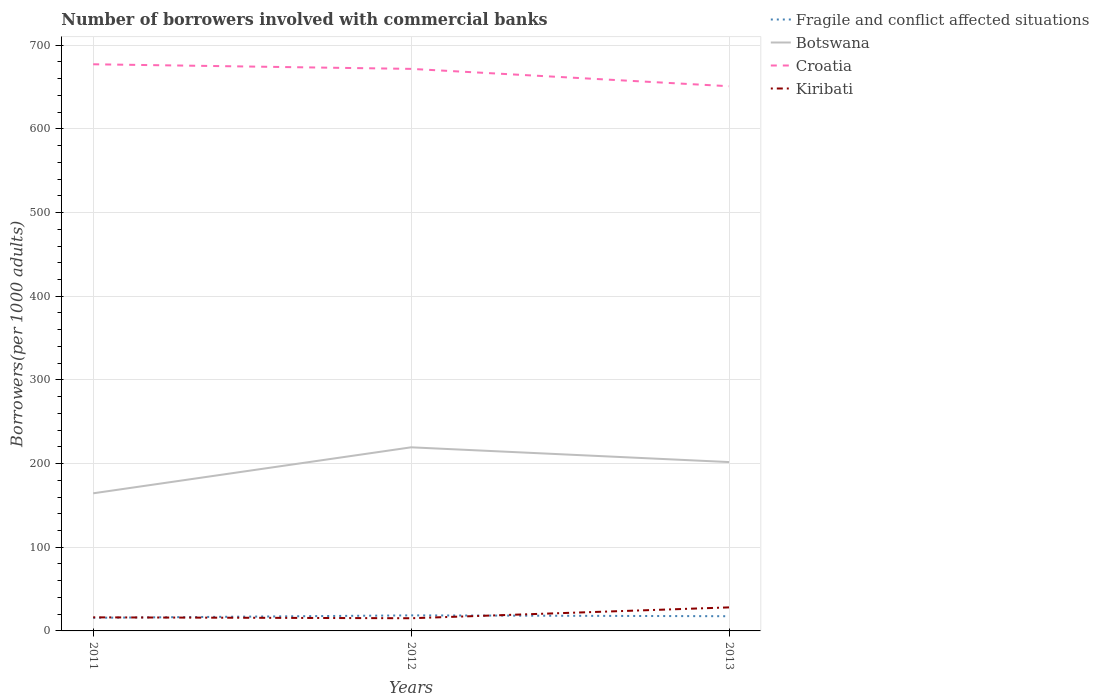How many different coloured lines are there?
Provide a short and direct response. 4. Does the line corresponding to Croatia intersect with the line corresponding to Kiribati?
Keep it short and to the point. No. Across all years, what is the maximum number of borrowers involved with commercial banks in Fragile and conflict affected situations?
Provide a short and direct response. 15.67. In which year was the number of borrowers involved with commercial banks in Fragile and conflict affected situations maximum?
Your answer should be very brief. 2011. What is the total number of borrowers involved with commercial banks in Fragile and conflict affected situations in the graph?
Provide a succinct answer. -2.91. What is the difference between the highest and the second highest number of borrowers involved with commercial banks in Botswana?
Offer a very short reply. 54.96. What is the difference between the highest and the lowest number of borrowers involved with commercial banks in Kiribati?
Give a very brief answer. 1. Is the number of borrowers involved with commercial banks in Fragile and conflict affected situations strictly greater than the number of borrowers involved with commercial banks in Croatia over the years?
Keep it short and to the point. Yes. Does the graph contain any zero values?
Offer a very short reply. No. Does the graph contain grids?
Keep it short and to the point. Yes. How many legend labels are there?
Provide a succinct answer. 4. How are the legend labels stacked?
Your answer should be very brief. Vertical. What is the title of the graph?
Offer a terse response. Number of borrowers involved with commercial banks. What is the label or title of the Y-axis?
Provide a succinct answer. Borrowers(per 1000 adults). What is the Borrowers(per 1000 adults) of Fragile and conflict affected situations in 2011?
Your response must be concise. 15.67. What is the Borrowers(per 1000 adults) in Botswana in 2011?
Offer a terse response. 164.48. What is the Borrowers(per 1000 adults) in Croatia in 2011?
Provide a succinct answer. 677.25. What is the Borrowers(per 1000 adults) in Kiribati in 2011?
Offer a terse response. 16.23. What is the Borrowers(per 1000 adults) of Fragile and conflict affected situations in 2012?
Offer a very short reply. 18.58. What is the Borrowers(per 1000 adults) of Botswana in 2012?
Keep it short and to the point. 219.44. What is the Borrowers(per 1000 adults) in Croatia in 2012?
Offer a terse response. 671.74. What is the Borrowers(per 1000 adults) of Kiribati in 2012?
Keep it short and to the point. 15.15. What is the Borrowers(per 1000 adults) in Fragile and conflict affected situations in 2013?
Provide a succinct answer. 17.58. What is the Borrowers(per 1000 adults) of Botswana in 2013?
Give a very brief answer. 201.82. What is the Borrowers(per 1000 adults) in Croatia in 2013?
Keep it short and to the point. 651.02. What is the Borrowers(per 1000 adults) in Kiribati in 2013?
Your answer should be very brief. 28.13. Across all years, what is the maximum Borrowers(per 1000 adults) of Fragile and conflict affected situations?
Give a very brief answer. 18.58. Across all years, what is the maximum Borrowers(per 1000 adults) of Botswana?
Keep it short and to the point. 219.44. Across all years, what is the maximum Borrowers(per 1000 adults) of Croatia?
Your answer should be very brief. 677.25. Across all years, what is the maximum Borrowers(per 1000 adults) of Kiribati?
Provide a succinct answer. 28.13. Across all years, what is the minimum Borrowers(per 1000 adults) of Fragile and conflict affected situations?
Provide a short and direct response. 15.67. Across all years, what is the minimum Borrowers(per 1000 adults) of Botswana?
Ensure brevity in your answer.  164.48. Across all years, what is the minimum Borrowers(per 1000 adults) in Croatia?
Offer a terse response. 651.02. Across all years, what is the minimum Borrowers(per 1000 adults) of Kiribati?
Give a very brief answer. 15.15. What is the total Borrowers(per 1000 adults) of Fragile and conflict affected situations in the graph?
Your response must be concise. 51.83. What is the total Borrowers(per 1000 adults) of Botswana in the graph?
Ensure brevity in your answer.  585.73. What is the total Borrowers(per 1000 adults) in Croatia in the graph?
Ensure brevity in your answer.  2000. What is the total Borrowers(per 1000 adults) in Kiribati in the graph?
Your answer should be compact. 59.51. What is the difference between the Borrowers(per 1000 adults) in Fragile and conflict affected situations in 2011 and that in 2012?
Provide a succinct answer. -2.91. What is the difference between the Borrowers(per 1000 adults) in Botswana in 2011 and that in 2012?
Your response must be concise. -54.96. What is the difference between the Borrowers(per 1000 adults) in Croatia in 2011 and that in 2012?
Keep it short and to the point. 5.51. What is the difference between the Borrowers(per 1000 adults) of Kiribati in 2011 and that in 2012?
Ensure brevity in your answer.  1.08. What is the difference between the Borrowers(per 1000 adults) in Fragile and conflict affected situations in 2011 and that in 2013?
Give a very brief answer. -1.91. What is the difference between the Borrowers(per 1000 adults) of Botswana in 2011 and that in 2013?
Provide a short and direct response. -37.34. What is the difference between the Borrowers(per 1000 adults) of Croatia in 2011 and that in 2013?
Offer a terse response. 26.23. What is the difference between the Borrowers(per 1000 adults) of Kiribati in 2011 and that in 2013?
Offer a terse response. -11.9. What is the difference between the Borrowers(per 1000 adults) of Fragile and conflict affected situations in 2012 and that in 2013?
Offer a terse response. 1. What is the difference between the Borrowers(per 1000 adults) in Botswana in 2012 and that in 2013?
Your answer should be compact. 17.62. What is the difference between the Borrowers(per 1000 adults) in Croatia in 2012 and that in 2013?
Ensure brevity in your answer.  20.72. What is the difference between the Borrowers(per 1000 adults) in Kiribati in 2012 and that in 2013?
Make the answer very short. -12.98. What is the difference between the Borrowers(per 1000 adults) in Fragile and conflict affected situations in 2011 and the Borrowers(per 1000 adults) in Botswana in 2012?
Provide a short and direct response. -203.77. What is the difference between the Borrowers(per 1000 adults) of Fragile and conflict affected situations in 2011 and the Borrowers(per 1000 adults) of Croatia in 2012?
Provide a short and direct response. -656.07. What is the difference between the Borrowers(per 1000 adults) of Fragile and conflict affected situations in 2011 and the Borrowers(per 1000 adults) of Kiribati in 2012?
Your answer should be compact. 0.52. What is the difference between the Borrowers(per 1000 adults) in Botswana in 2011 and the Borrowers(per 1000 adults) in Croatia in 2012?
Your answer should be compact. -507.26. What is the difference between the Borrowers(per 1000 adults) of Botswana in 2011 and the Borrowers(per 1000 adults) of Kiribati in 2012?
Provide a short and direct response. 149.32. What is the difference between the Borrowers(per 1000 adults) of Croatia in 2011 and the Borrowers(per 1000 adults) of Kiribati in 2012?
Provide a succinct answer. 662.09. What is the difference between the Borrowers(per 1000 adults) in Fragile and conflict affected situations in 2011 and the Borrowers(per 1000 adults) in Botswana in 2013?
Make the answer very short. -186.15. What is the difference between the Borrowers(per 1000 adults) of Fragile and conflict affected situations in 2011 and the Borrowers(per 1000 adults) of Croatia in 2013?
Ensure brevity in your answer.  -635.35. What is the difference between the Borrowers(per 1000 adults) of Fragile and conflict affected situations in 2011 and the Borrowers(per 1000 adults) of Kiribati in 2013?
Offer a terse response. -12.46. What is the difference between the Borrowers(per 1000 adults) in Botswana in 2011 and the Borrowers(per 1000 adults) in Croatia in 2013?
Ensure brevity in your answer.  -486.54. What is the difference between the Borrowers(per 1000 adults) in Botswana in 2011 and the Borrowers(per 1000 adults) in Kiribati in 2013?
Ensure brevity in your answer.  136.35. What is the difference between the Borrowers(per 1000 adults) of Croatia in 2011 and the Borrowers(per 1000 adults) of Kiribati in 2013?
Offer a terse response. 649.12. What is the difference between the Borrowers(per 1000 adults) of Fragile and conflict affected situations in 2012 and the Borrowers(per 1000 adults) of Botswana in 2013?
Ensure brevity in your answer.  -183.23. What is the difference between the Borrowers(per 1000 adults) in Fragile and conflict affected situations in 2012 and the Borrowers(per 1000 adults) in Croatia in 2013?
Your answer should be compact. -632.43. What is the difference between the Borrowers(per 1000 adults) in Fragile and conflict affected situations in 2012 and the Borrowers(per 1000 adults) in Kiribati in 2013?
Offer a terse response. -9.55. What is the difference between the Borrowers(per 1000 adults) in Botswana in 2012 and the Borrowers(per 1000 adults) in Croatia in 2013?
Your answer should be very brief. -431.58. What is the difference between the Borrowers(per 1000 adults) in Botswana in 2012 and the Borrowers(per 1000 adults) in Kiribati in 2013?
Your response must be concise. 191.31. What is the difference between the Borrowers(per 1000 adults) in Croatia in 2012 and the Borrowers(per 1000 adults) in Kiribati in 2013?
Provide a short and direct response. 643.61. What is the average Borrowers(per 1000 adults) in Fragile and conflict affected situations per year?
Keep it short and to the point. 17.28. What is the average Borrowers(per 1000 adults) of Botswana per year?
Offer a very short reply. 195.24. What is the average Borrowers(per 1000 adults) in Croatia per year?
Keep it short and to the point. 666.67. What is the average Borrowers(per 1000 adults) in Kiribati per year?
Your answer should be very brief. 19.84. In the year 2011, what is the difference between the Borrowers(per 1000 adults) of Fragile and conflict affected situations and Borrowers(per 1000 adults) of Botswana?
Offer a terse response. -148.81. In the year 2011, what is the difference between the Borrowers(per 1000 adults) in Fragile and conflict affected situations and Borrowers(per 1000 adults) in Croatia?
Keep it short and to the point. -661.58. In the year 2011, what is the difference between the Borrowers(per 1000 adults) in Fragile and conflict affected situations and Borrowers(per 1000 adults) in Kiribati?
Offer a terse response. -0.56. In the year 2011, what is the difference between the Borrowers(per 1000 adults) in Botswana and Borrowers(per 1000 adults) in Croatia?
Provide a short and direct response. -512.77. In the year 2011, what is the difference between the Borrowers(per 1000 adults) of Botswana and Borrowers(per 1000 adults) of Kiribati?
Your answer should be very brief. 148.25. In the year 2011, what is the difference between the Borrowers(per 1000 adults) of Croatia and Borrowers(per 1000 adults) of Kiribati?
Provide a short and direct response. 661.02. In the year 2012, what is the difference between the Borrowers(per 1000 adults) of Fragile and conflict affected situations and Borrowers(per 1000 adults) of Botswana?
Ensure brevity in your answer.  -200.86. In the year 2012, what is the difference between the Borrowers(per 1000 adults) of Fragile and conflict affected situations and Borrowers(per 1000 adults) of Croatia?
Your response must be concise. -653.16. In the year 2012, what is the difference between the Borrowers(per 1000 adults) in Fragile and conflict affected situations and Borrowers(per 1000 adults) in Kiribati?
Your response must be concise. 3.43. In the year 2012, what is the difference between the Borrowers(per 1000 adults) in Botswana and Borrowers(per 1000 adults) in Croatia?
Your answer should be very brief. -452.3. In the year 2012, what is the difference between the Borrowers(per 1000 adults) of Botswana and Borrowers(per 1000 adults) of Kiribati?
Make the answer very short. 204.28. In the year 2012, what is the difference between the Borrowers(per 1000 adults) in Croatia and Borrowers(per 1000 adults) in Kiribati?
Give a very brief answer. 656.59. In the year 2013, what is the difference between the Borrowers(per 1000 adults) in Fragile and conflict affected situations and Borrowers(per 1000 adults) in Botswana?
Give a very brief answer. -184.24. In the year 2013, what is the difference between the Borrowers(per 1000 adults) of Fragile and conflict affected situations and Borrowers(per 1000 adults) of Croatia?
Your answer should be very brief. -633.44. In the year 2013, what is the difference between the Borrowers(per 1000 adults) in Fragile and conflict affected situations and Borrowers(per 1000 adults) in Kiribati?
Your answer should be very brief. -10.55. In the year 2013, what is the difference between the Borrowers(per 1000 adults) of Botswana and Borrowers(per 1000 adults) of Croatia?
Provide a succinct answer. -449.2. In the year 2013, what is the difference between the Borrowers(per 1000 adults) in Botswana and Borrowers(per 1000 adults) in Kiribati?
Keep it short and to the point. 173.69. In the year 2013, what is the difference between the Borrowers(per 1000 adults) of Croatia and Borrowers(per 1000 adults) of Kiribati?
Offer a very short reply. 622.89. What is the ratio of the Borrowers(per 1000 adults) in Fragile and conflict affected situations in 2011 to that in 2012?
Keep it short and to the point. 0.84. What is the ratio of the Borrowers(per 1000 adults) in Botswana in 2011 to that in 2012?
Offer a very short reply. 0.75. What is the ratio of the Borrowers(per 1000 adults) of Croatia in 2011 to that in 2012?
Offer a terse response. 1.01. What is the ratio of the Borrowers(per 1000 adults) of Kiribati in 2011 to that in 2012?
Provide a short and direct response. 1.07. What is the ratio of the Borrowers(per 1000 adults) in Fragile and conflict affected situations in 2011 to that in 2013?
Your answer should be very brief. 0.89. What is the ratio of the Borrowers(per 1000 adults) of Botswana in 2011 to that in 2013?
Your answer should be compact. 0.81. What is the ratio of the Borrowers(per 1000 adults) in Croatia in 2011 to that in 2013?
Make the answer very short. 1.04. What is the ratio of the Borrowers(per 1000 adults) in Kiribati in 2011 to that in 2013?
Make the answer very short. 0.58. What is the ratio of the Borrowers(per 1000 adults) of Fragile and conflict affected situations in 2012 to that in 2013?
Offer a terse response. 1.06. What is the ratio of the Borrowers(per 1000 adults) in Botswana in 2012 to that in 2013?
Your answer should be compact. 1.09. What is the ratio of the Borrowers(per 1000 adults) in Croatia in 2012 to that in 2013?
Keep it short and to the point. 1.03. What is the ratio of the Borrowers(per 1000 adults) of Kiribati in 2012 to that in 2013?
Give a very brief answer. 0.54. What is the difference between the highest and the second highest Borrowers(per 1000 adults) in Fragile and conflict affected situations?
Your response must be concise. 1. What is the difference between the highest and the second highest Borrowers(per 1000 adults) of Botswana?
Your answer should be compact. 17.62. What is the difference between the highest and the second highest Borrowers(per 1000 adults) in Croatia?
Your response must be concise. 5.51. What is the difference between the highest and the second highest Borrowers(per 1000 adults) of Kiribati?
Your response must be concise. 11.9. What is the difference between the highest and the lowest Borrowers(per 1000 adults) in Fragile and conflict affected situations?
Your answer should be very brief. 2.91. What is the difference between the highest and the lowest Borrowers(per 1000 adults) of Botswana?
Offer a terse response. 54.96. What is the difference between the highest and the lowest Borrowers(per 1000 adults) in Croatia?
Provide a short and direct response. 26.23. What is the difference between the highest and the lowest Borrowers(per 1000 adults) of Kiribati?
Ensure brevity in your answer.  12.98. 